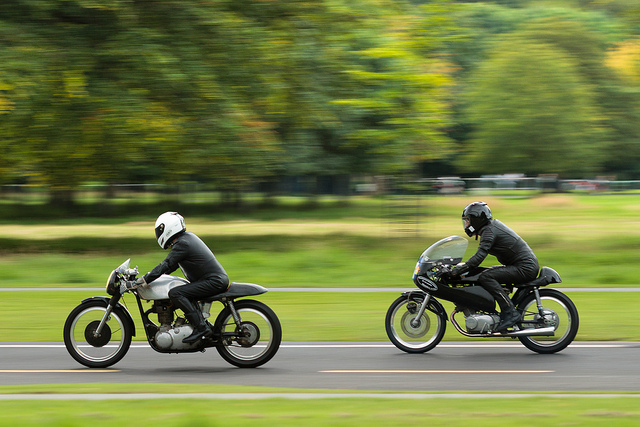What can be inferred about the riders' experience level? Given their composed postures and the precision with which they are handling their motorcycles at speed, it is likely that they are experienced riders who are comfortable with high-speed riding and possibly familiar with racing techniques. 